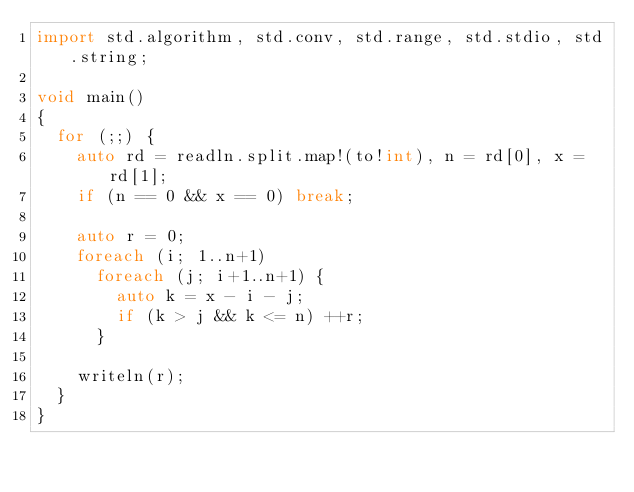<code> <loc_0><loc_0><loc_500><loc_500><_D_>import std.algorithm, std.conv, std.range, std.stdio, std.string;

void main()
{
  for (;;) {
    auto rd = readln.split.map!(to!int), n = rd[0], x = rd[1];
    if (n == 0 && x == 0) break;

    auto r = 0;
    foreach (i; 1..n+1)
      foreach (j; i+1..n+1) {
        auto k = x - i - j;
        if (k > j && k <= n) ++r;
      }

    writeln(r);
  }
}</code> 